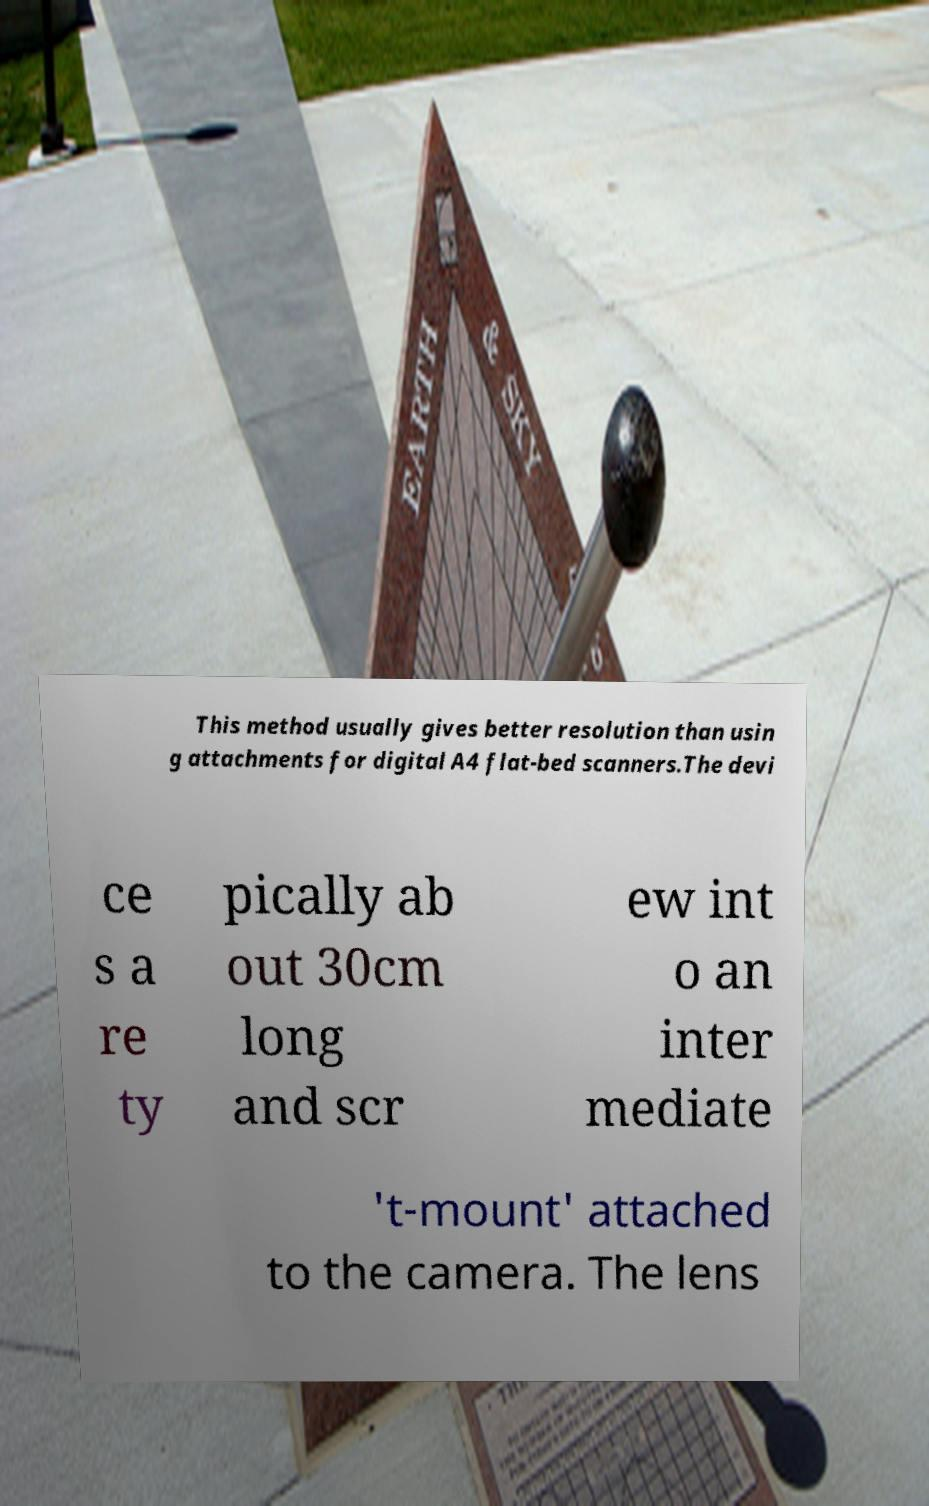Can you accurately transcribe the text from the provided image for me? This method usually gives better resolution than usin g attachments for digital A4 flat-bed scanners.The devi ce s a re ty pically ab out 30cm long and scr ew int o an inter mediate 't-mount' attached to the camera. The lens 